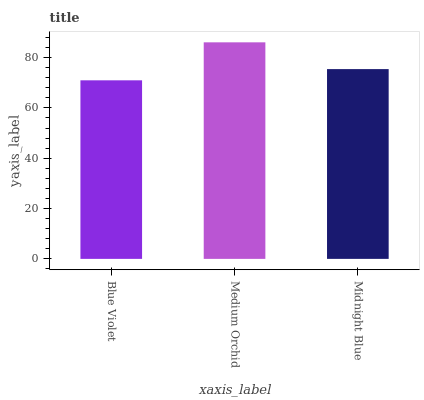Is Blue Violet the minimum?
Answer yes or no. Yes. Is Medium Orchid the maximum?
Answer yes or no. Yes. Is Midnight Blue the minimum?
Answer yes or no. No. Is Midnight Blue the maximum?
Answer yes or no. No. Is Medium Orchid greater than Midnight Blue?
Answer yes or no. Yes. Is Midnight Blue less than Medium Orchid?
Answer yes or no. Yes. Is Midnight Blue greater than Medium Orchid?
Answer yes or no. No. Is Medium Orchid less than Midnight Blue?
Answer yes or no. No. Is Midnight Blue the high median?
Answer yes or no. Yes. Is Midnight Blue the low median?
Answer yes or no. Yes. Is Blue Violet the high median?
Answer yes or no. No. Is Blue Violet the low median?
Answer yes or no. No. 